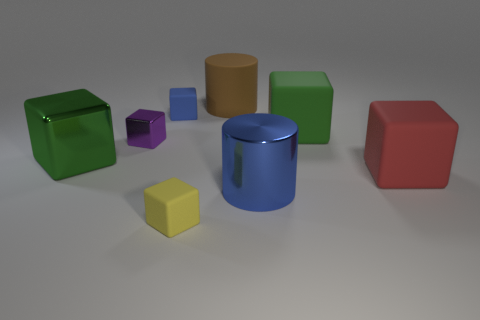The large cube that is both to the right of the blue cube and to the left of the red cube is what color? The large cube you're referring to, which is positioned between the blue cube on its left and the red cube on its right, is green in color. This setting creates a striking contrast between the cubes, highlighting the variety of colors presented. 